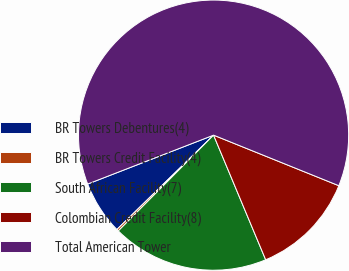Convert chart to OTSL. <chart><loc_0><loc_0><loc_500><loc_500><pie_chart><fcel>BR Towers Debentures(4)<fcel>BR Towers Credit Facility(4)<fcel>South African Facility(7)<fcel>Colombian Credit Facility(8)<fcel>Total American Tower<nl><fcel>6.41%<fcel>0.24%<fcel>18.76%<fcel>12.59%<fcel>62.0%<nl></chart> 